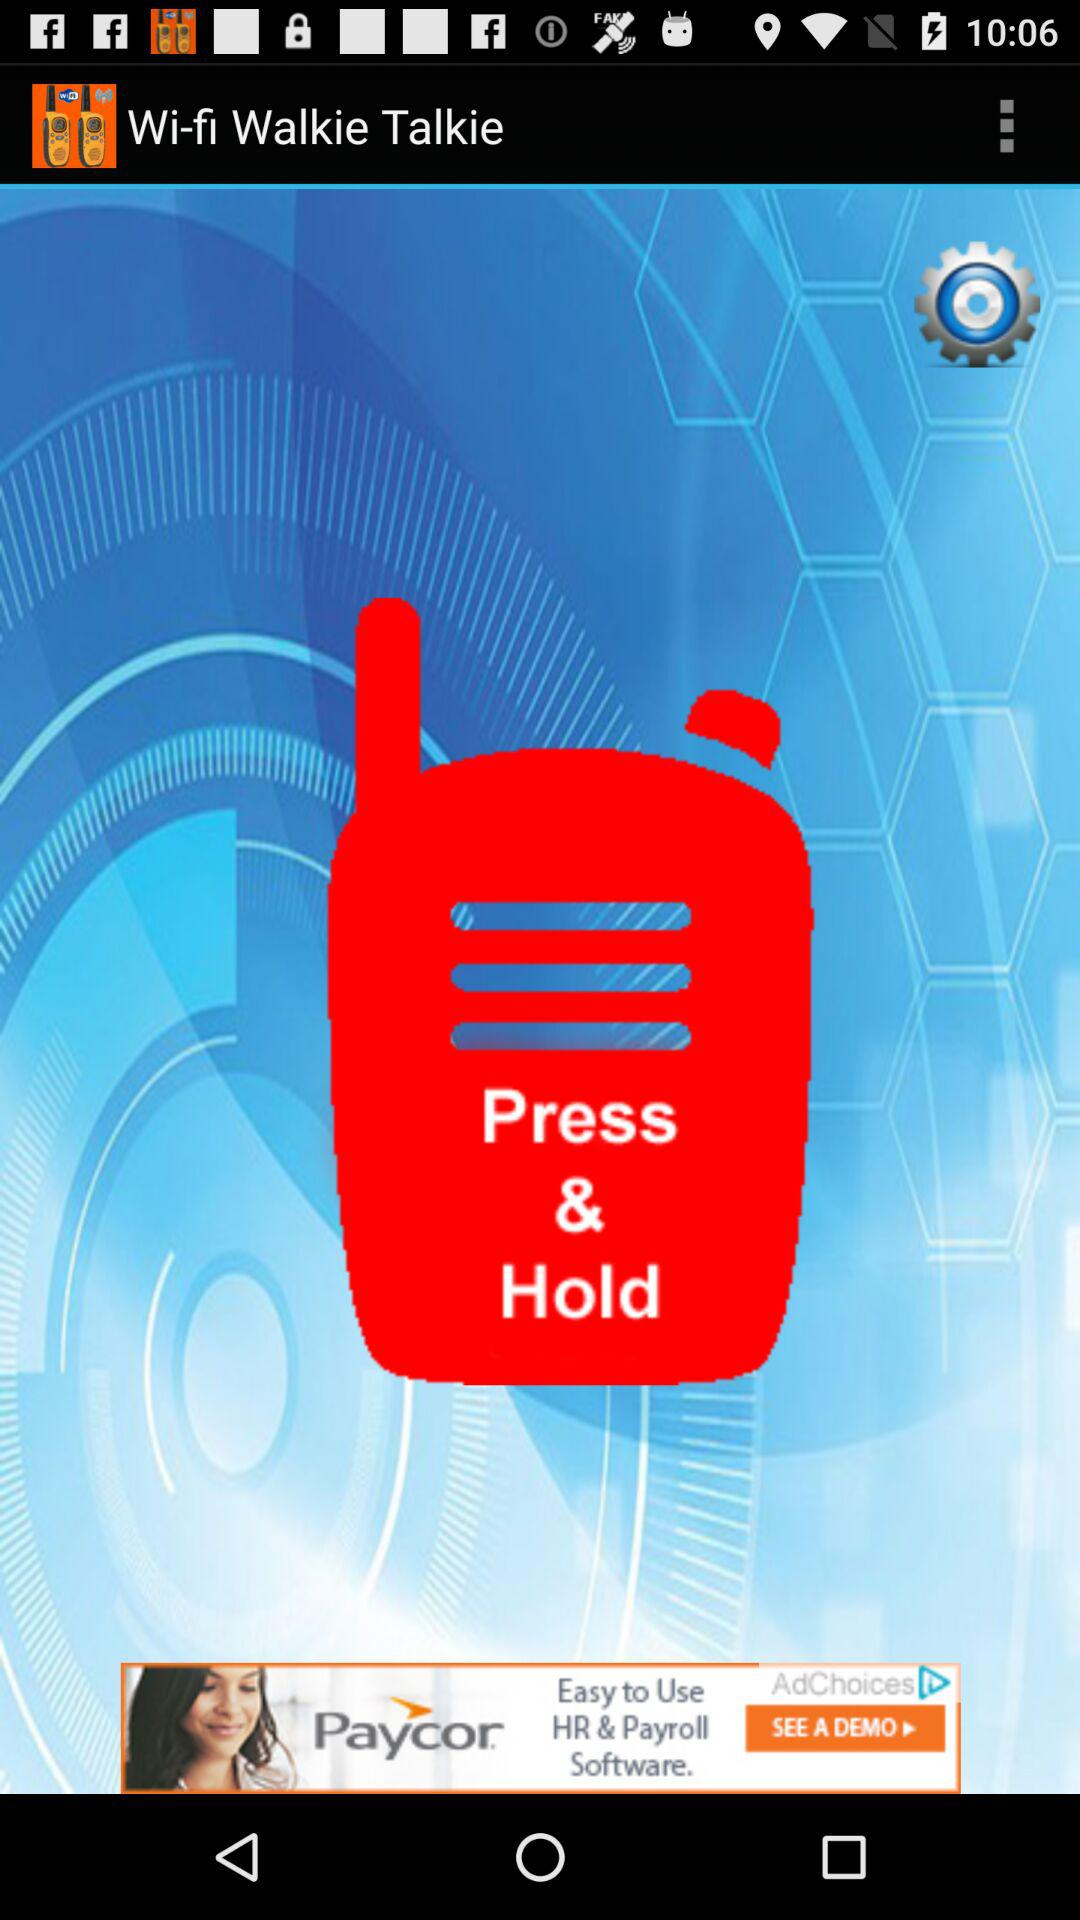What is the name of the application? The name of the application is "Wi-fi Walkie Talkie". 